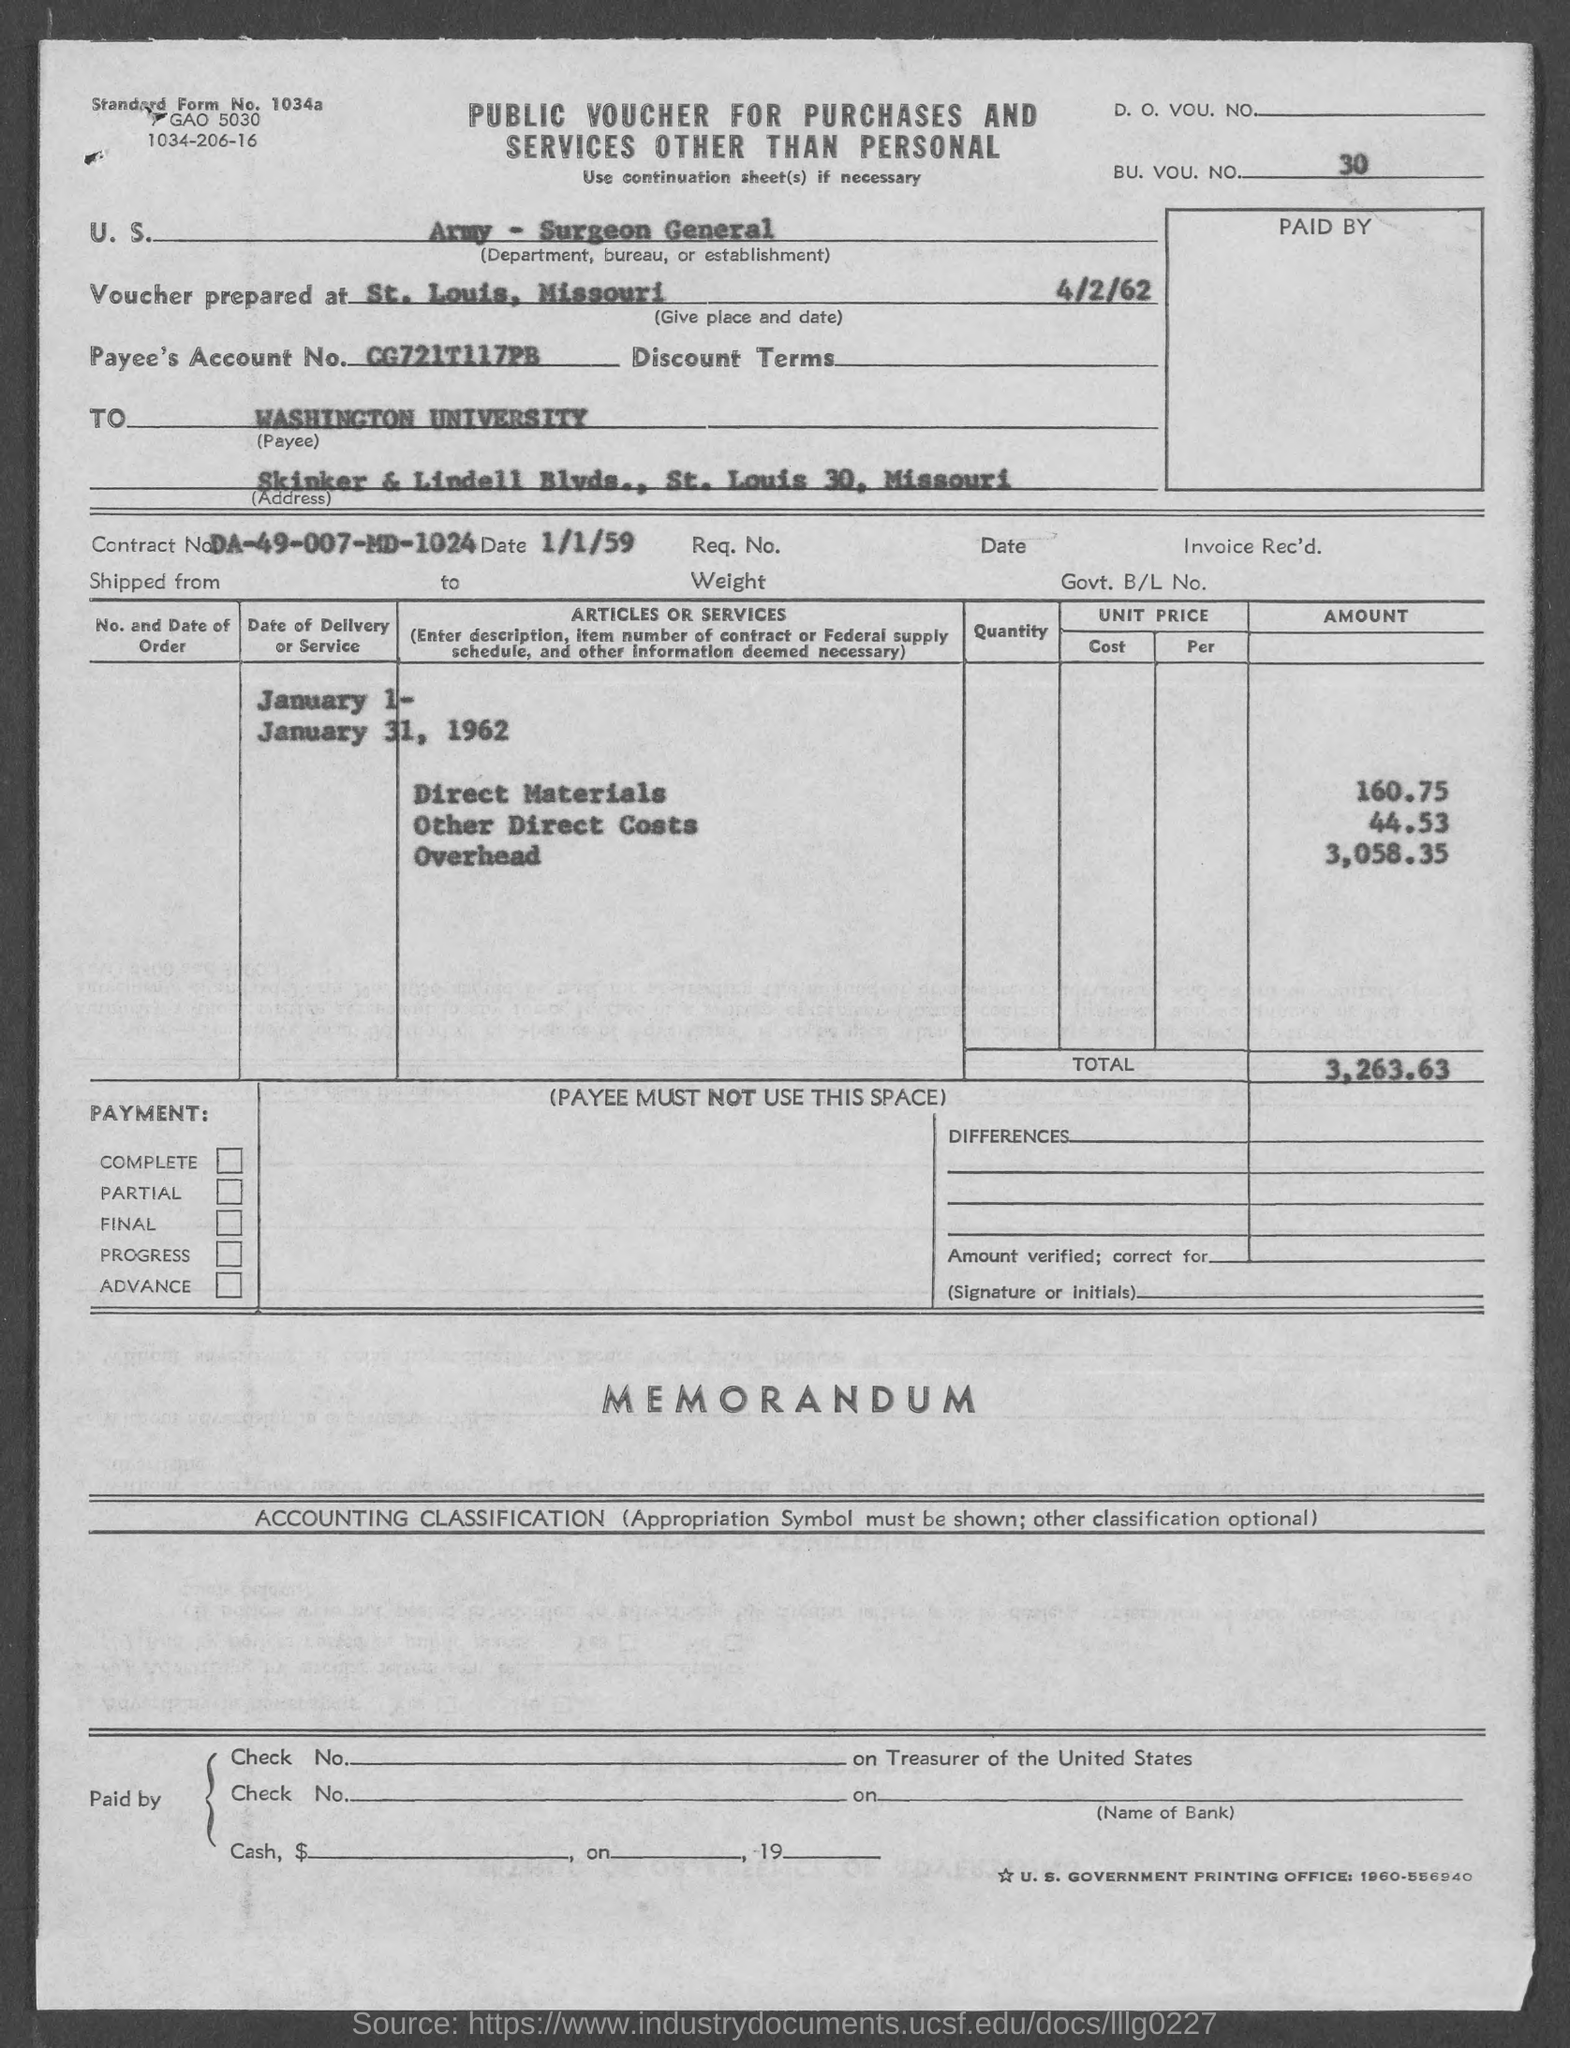Identify some key points in this picture. The total amount mentioned in the voucher is 3,263.63. The voucher mentions the BU. VOU. NO. as 30... The voucher was prepared in St. Louis, Missouri on April 2, 1962. The payee's account number, as stated in the voucher, is CG721T117PB.. The Contract No. provided in the voucher is DA-49-007-MD-1024. 